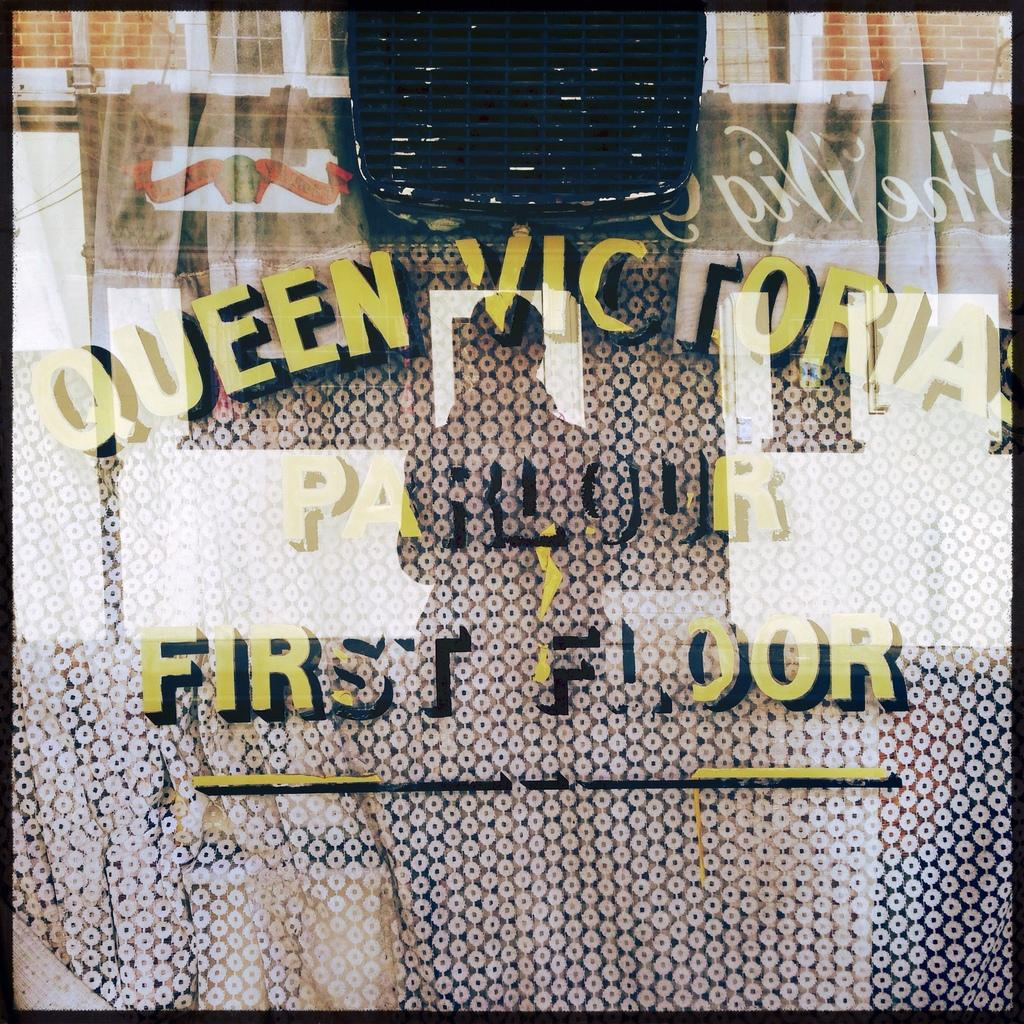<image>
Summarize the visual content of the image. a window that says 'queen victoria parlour first floor' on it 